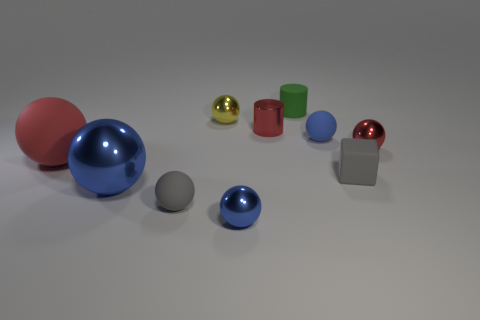There is a blue ball that is to the left of the small blue object that is in front of the tiny gray matte sphere; what is its material?
Your response must be concise. Metal. What number of other things are there of the same shape as the blue matte thing?
Your response must be concise. 6. There is a tiny red thing to the right of the tiny green rubber cylinder; is it the same shape as the small gray thing that is to the left of the matte cylinder?
Offer a very short reply. Yes. What material is the yellow ball?
Ensure brevity in your answer.  Metal. What is the gray thing behind the large metal ball made of?
Ensure brevity in your answer.  Rubber. Is there any other thing that is the same color as the tiny rubber cylinder?
Provide a short and direct response. No. There is a red ball that is the same material as the tiny green object; what size is it?
Make the answer very short. Large. How many large things are either purple metal cubes or yellow balls?
Ensure brevity in your answer.  0. What size is the red metal object behind the tiny red metal thing right of the small gray thing to the right of the red cylinder?
Your answer should be very brief. Small. How many purple things are the same size as the yellow ball?
Your response must be concise. 0. 